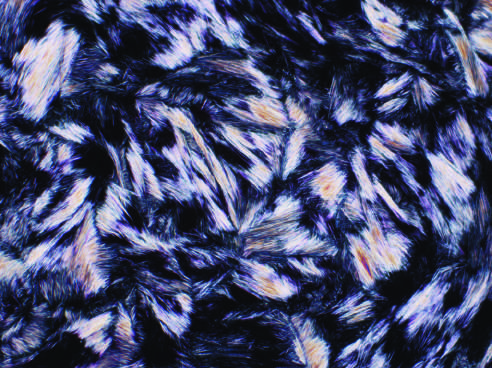re early organization of intraalveolar exudates, seen in areas to be streaming through the needle shaped and negatively birefringent under polarized light?
Answer the question using a single word or phrase. No 